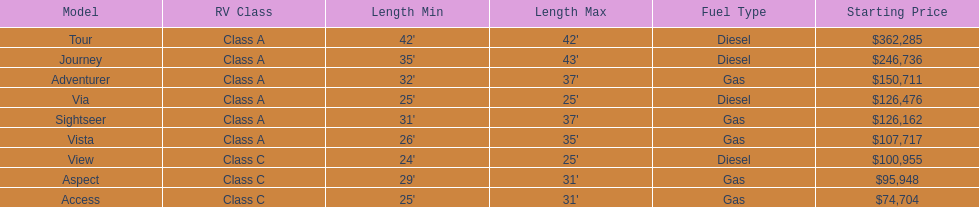Does the tour take diesel or gas? Diesel. 